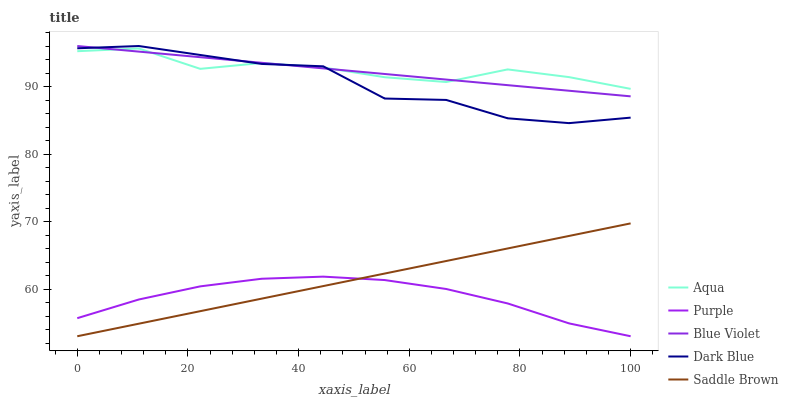Does Purple have the minimum area under the curve?
Answer yes or no. Yes. Does Aqua have the maximum area under the curve?
Answer yes or no. Yes. Does Dark Blue have the minimum area under the curve?
Answer yes or no. No. Does Dark Blue have the maximum area under the curve?
Answer yes or no. No. Is Saddle Brown the smoothest?
Answer yes or no. Yes. Is Dark Blue the roughest?
Answer yes or no. Yes. Is Aqua the smoothest?
Answer yes or no. No. Is Aqua the roughest?
Answer yes or no. No. Does Purple have the lowest value?
Answer yes or no. Yes. Does Dark Blue have the lowest value?
Answer yes or no. No. Does Blue Violet have the highest value?
Answer yes or no. Yes. Does Aqua have the highest value?
Answer yes or no. No. Is Saddle Brown less than Dark Blue?
Answer yes or no. Yes. Is Blue Violet greater than Saddle Brown?
Answer yes or no. Yes. Does Saddle Brown intersect Purple?
Answer yes or no. Yes. Is Saddle Brown less than Purple?
Answer yes or no. No. Is Saddle Brown greater than Purple?
Answer yes or no. No. Does Saddle Brown intersect Dark Blue?
Answer yes or no. No. 